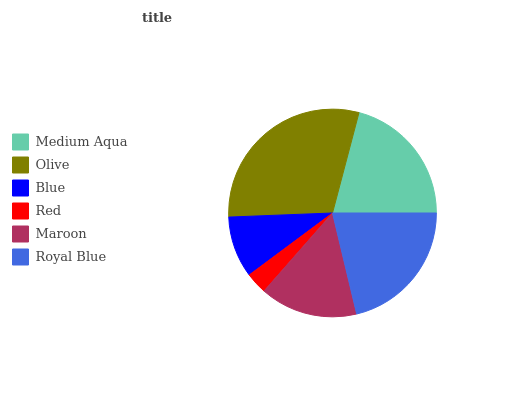Is Red the minimum?
Answer yes or no. Yes. Is Olive the maximum?
Answer yes or no. Yes. Is Blue the minimum?
Answer yes or no. No. Is Blue the maximum?
Answer yes or no. No. Is Olive greater than Blue?
Answer yes or no. Yes. Is Blue less than Olive?
Answer yes or no. Yes. Is Blue greater than Olive?
Answer yes or no. No. Is Olive less than Blue?
Answer yes or no. No. Is Medium Aqua the high median?
Answer yes or no. Yes. Is Maroon the low median?
Answer yes or no. Yes. Is Royal Blue the high median?
Answer yes or no. No. Is Medium Aqua the low median?
Answer yes or no. No. 